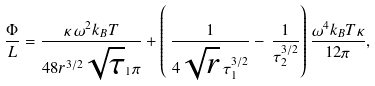Convert formula to latex. <formula><loc_0><loc_0><loc_500><loc_500>\frac { \Phi } { L } = { \frac { \kappa \, \omega ^ { 2 } k _ { B } T } { 4 8 r ^ { 3 / 2 } \sqrt { \tau } _ { 1 } \pi } } + \left ( \, { \frac { 1 } { 4 \sqrt { r } \, \tau _ { 1 } ^ { 3 / 2 } } } - \, { \frac { 1 } { \tau _ { 2 } ^ { 3 / 2 } } } \right ) \frac { \omega ^ { 4 } k _ { B } T \kappa } { 1 2 \pi } ,</formula> 